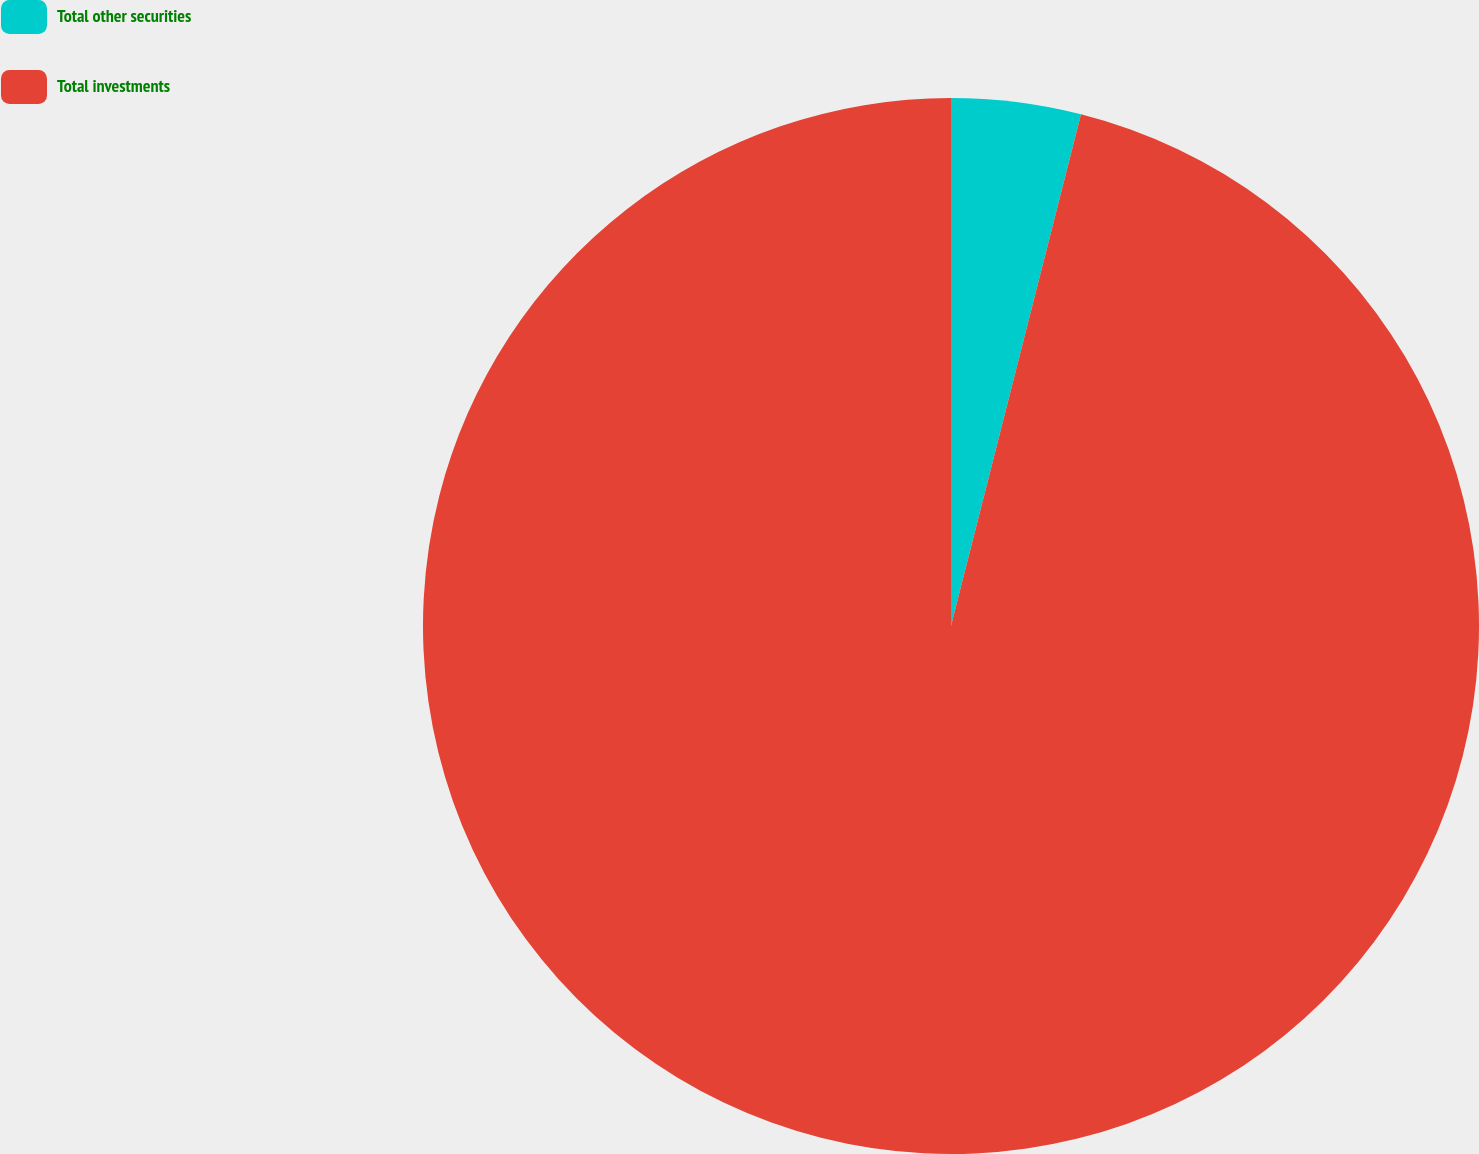<chart> <loc_0><loc_0><loc_500><loc_500><pie_chart><fcel>Total other securities<fcel>Total investments<nl><fcel>3.96%<fcel>96.04%<nl></chart> 